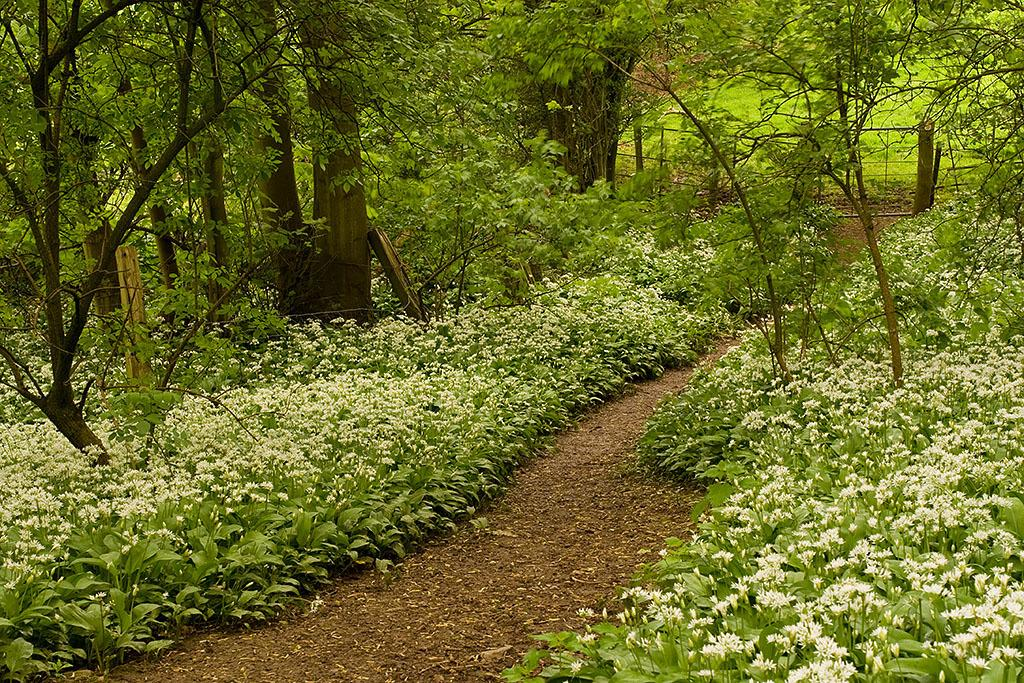What can be seen in the foreground of the image? There is a path in the foreground of the image. What is located on either side of the path? There are plants and flowers on either side of the path. Are there any other types of vegetation present in the image? Yes, there are trees on either side of the path. What type of board game is being played on the path in the image? There is no board game present in the image; it features a path with plants, flowers, and trees on either side. 